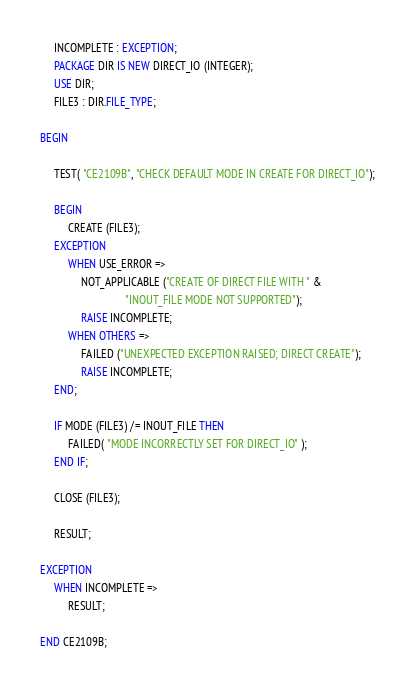<code> <loc_0><loc_0><loc_500><loc_500><_Ada_>
     INCOMPLETE : EXCEPTION;
     PACKAGE DIR IS NEW DIRECT_IO (INTEGER);
     USE DIR;
     FILE3 : DIR.FILE_TYPE;

BEGIN

     TEST( "CE2109B", "CHECK DEFAULT MODE IN CREATE FOR DIRECT_IO");

     BEGIN
          CREATE (FILE3);
     EXCEPTION
          WHEN USE_ERROR =>
               NOT_APPLICABLE ("CREATE OF DIRECT FILE WITH " &
                               "INOUT_FILE MODE NOT SUPPORTED");
               RAISE INCOMPLETE;
          WHEN OTHERS =>
               FAILED ("UNEXPECTED EXCEPTION RAISED; DIRECT CREATE");
               RAISE INCOMPLETE;
     END;

     IF MODE (FILE3) /= INOUT_FILE THEN
          FAILED( "MODE INCORRECTLY SET FOR DIRECT_IO" );
     END IF;

     CLOSE (FILE3);

     RESULT;

EXCEPTION
     WHEN INCOMPLETE =>
          RESULT;

END CE2109B;
</code> 